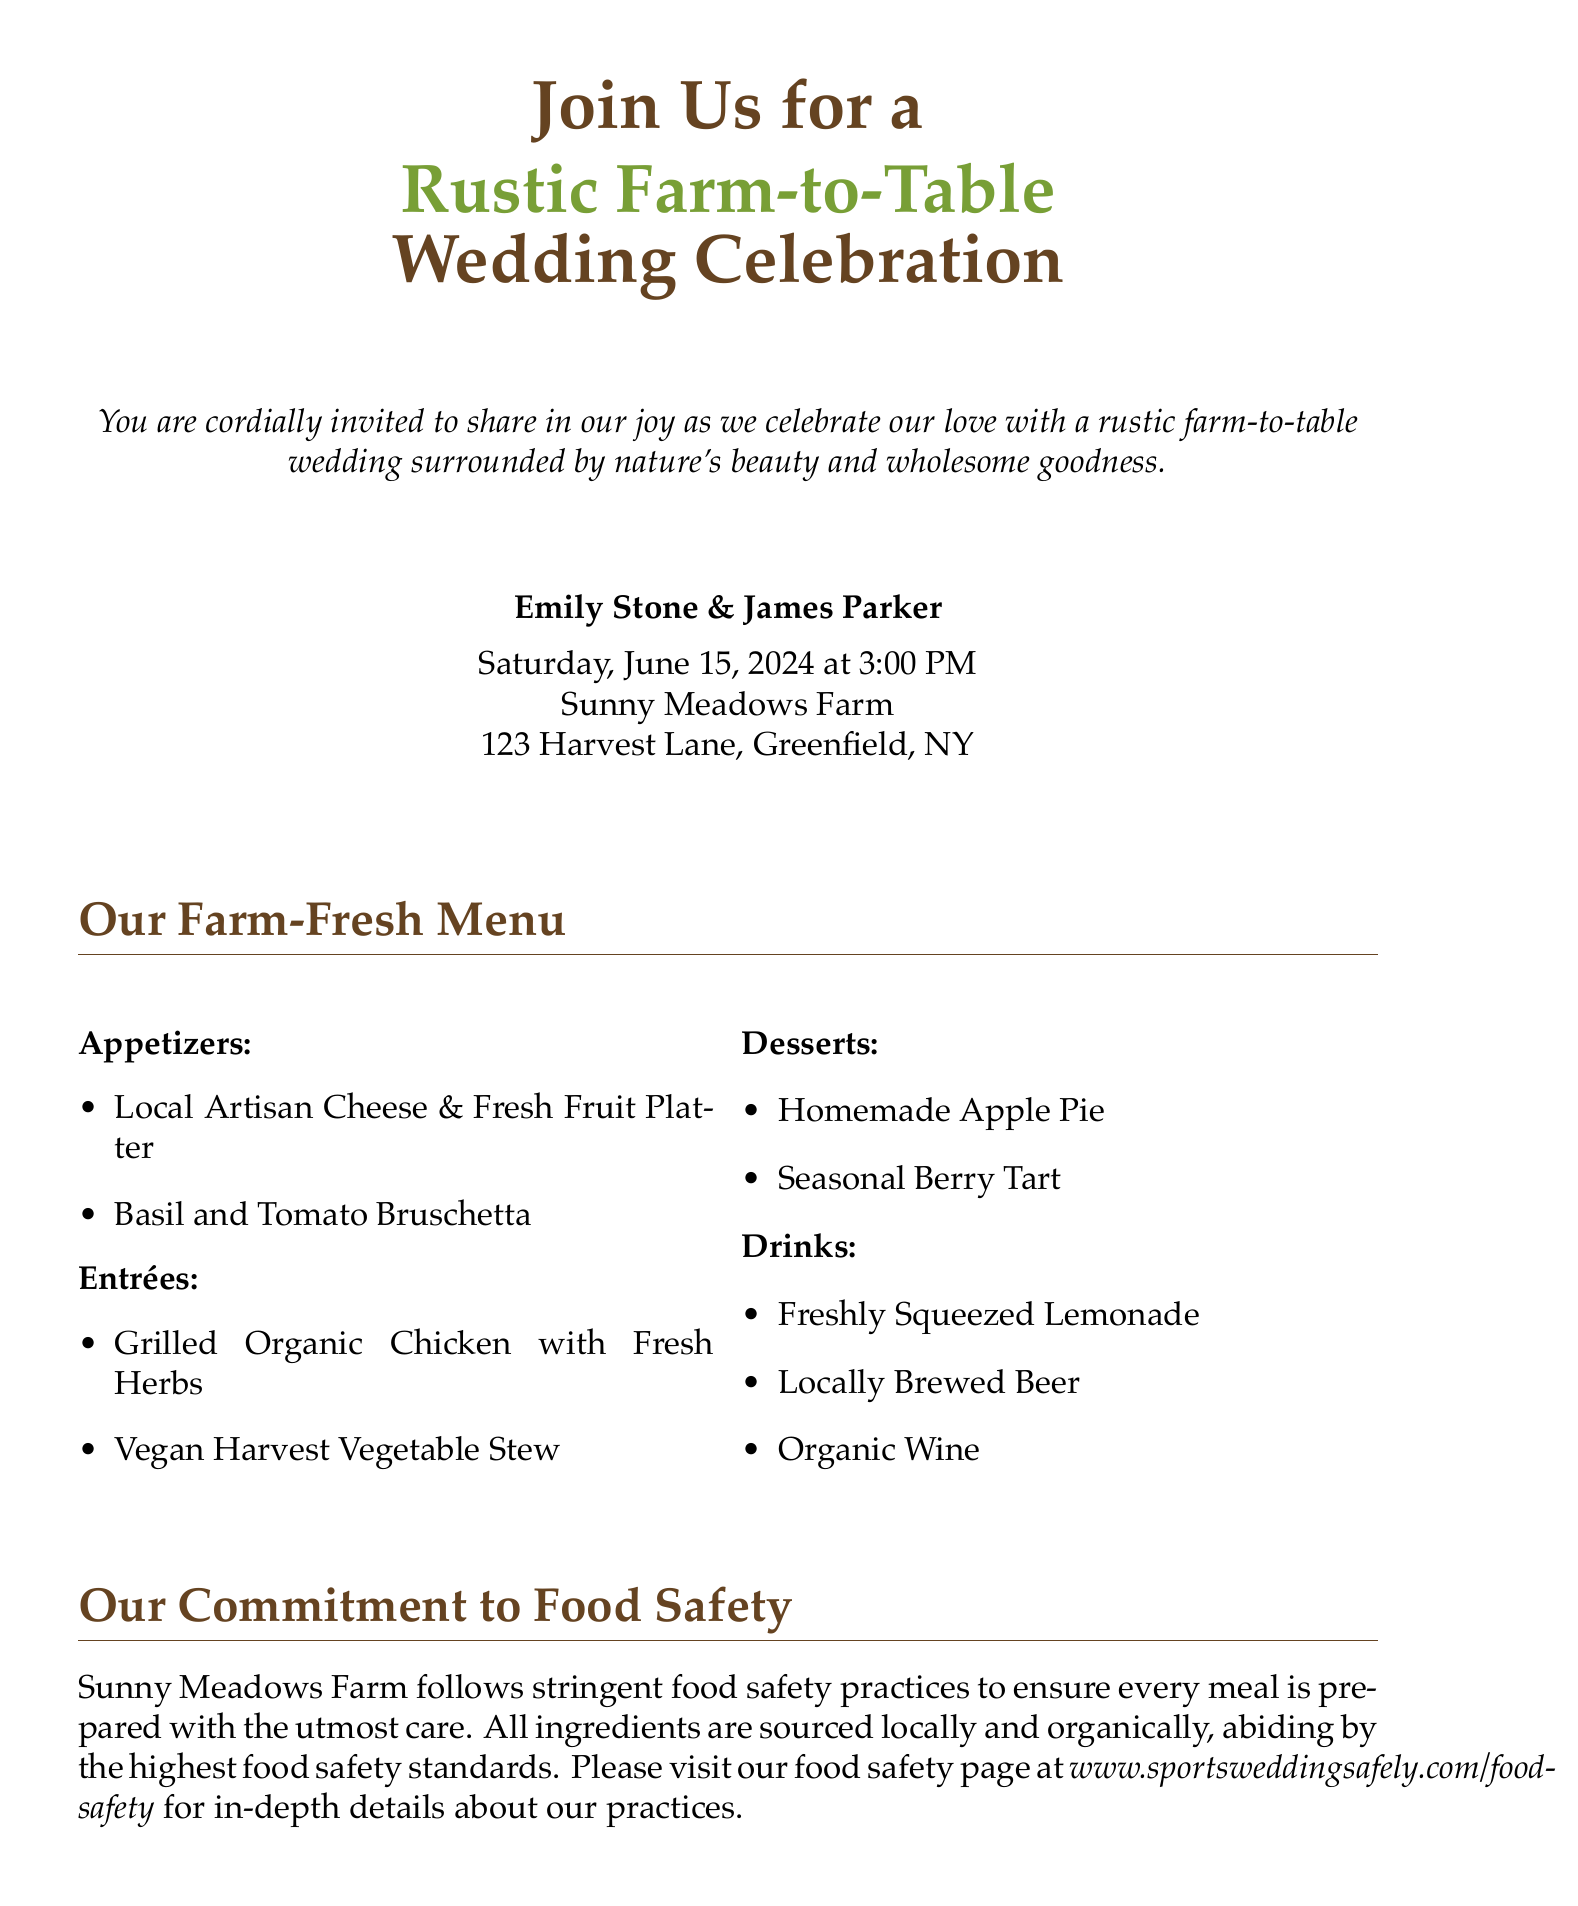What is the date of the wedding? The wedding date is explicitly mentioned in the document, which is Saturday, June 15, 2024.
Answer: June 15, 2024 Who are the couple getting married? The names of the couple are listed in the invitation section of the document.
Answer: Emily Stone & James Parker What type of menu is showcased? The document mentions it is a rustic farm-to-table menu.
Answer: Farm-to-Table What is the venue for the wedding? The venue is stated in the wedding details section of the document, specifically named Sunny Meadows Farm.
Answer: Sunny Meadows Farm What should guests inform about in the RSVP? The RSVP section specifies that guests should inform about dietary restrictions or allergies.
Answer: Dietary restrictions or allergies What time does the wedding ceremony start? The time for the wedding ceremony is stated in the invitation details.
Answer: 3:00 PM What kind of attire is requested? The invitation specifies what type of attire is appropriate for the event.
Answer: Casual Attire What safety practices are mentioned? The document mentions that stringent food safety practices are followed at Sunny Meadows Farm.
Answer: Stringent food safety practices What is the contact email for RSVPs? The email for RSVPs is listed in the document for guest convenience.
Answer: rsvp@rusticwedding.com 